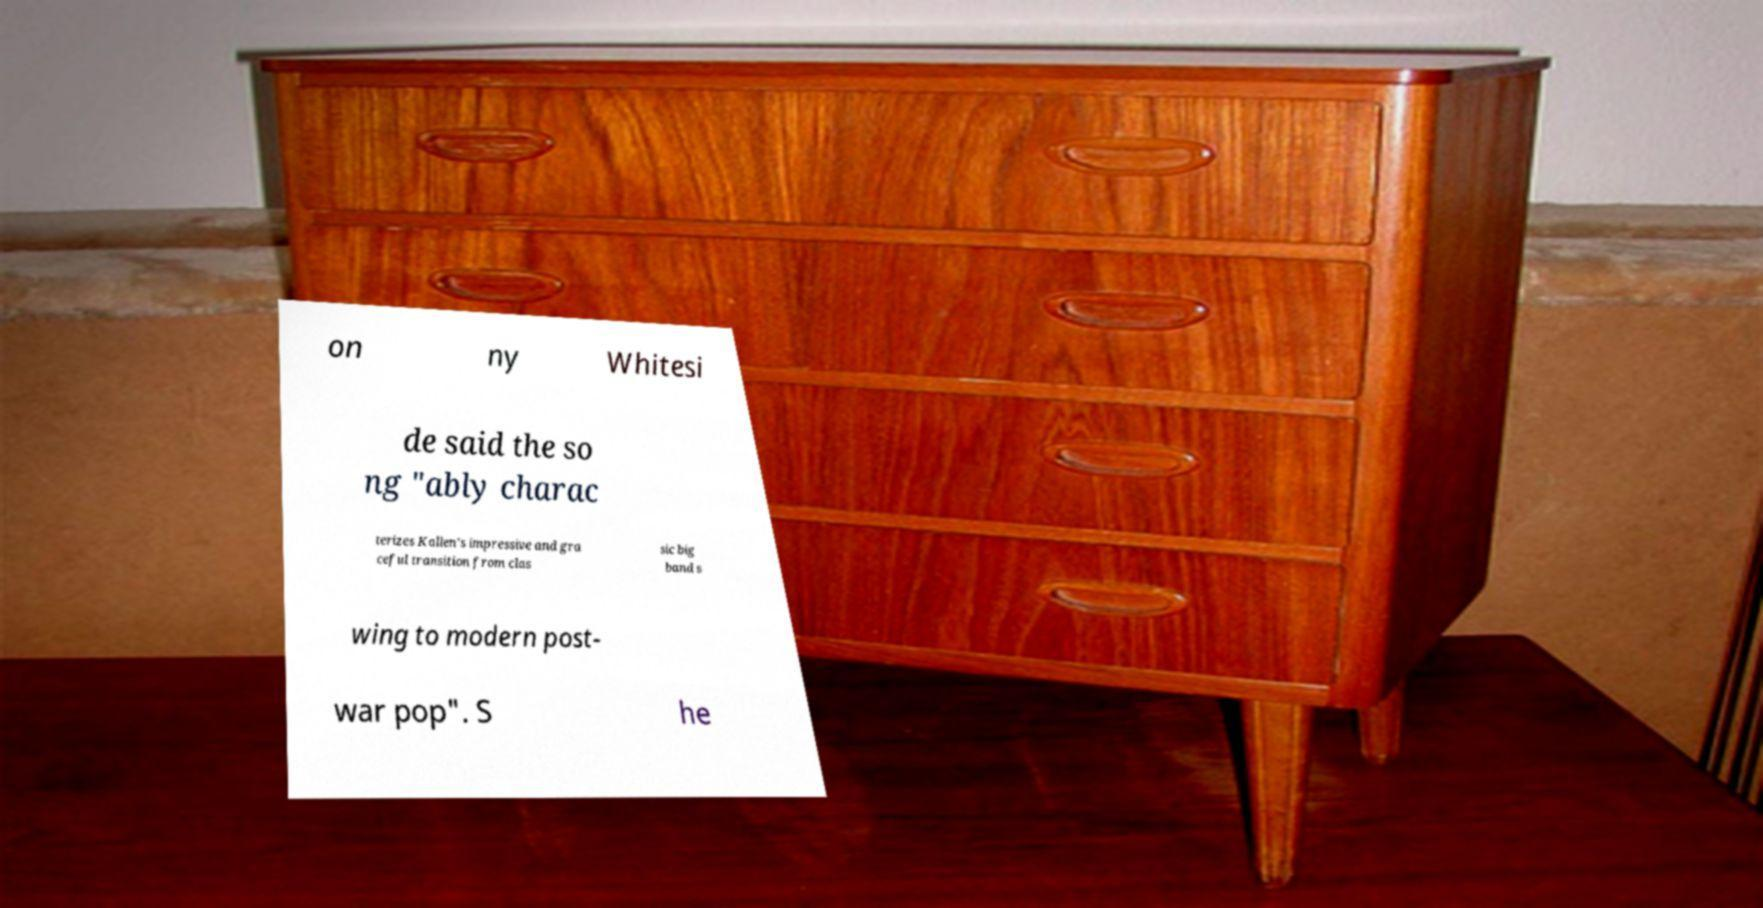There's text embedded in this image that I need extracted. Can you transcribe it verbatim? on ny Whitesi de said the so ng "ably charac terizes Kallen’s impressive and gra ceful transition from clas sic big band s wing to modern post- war pop". S he 